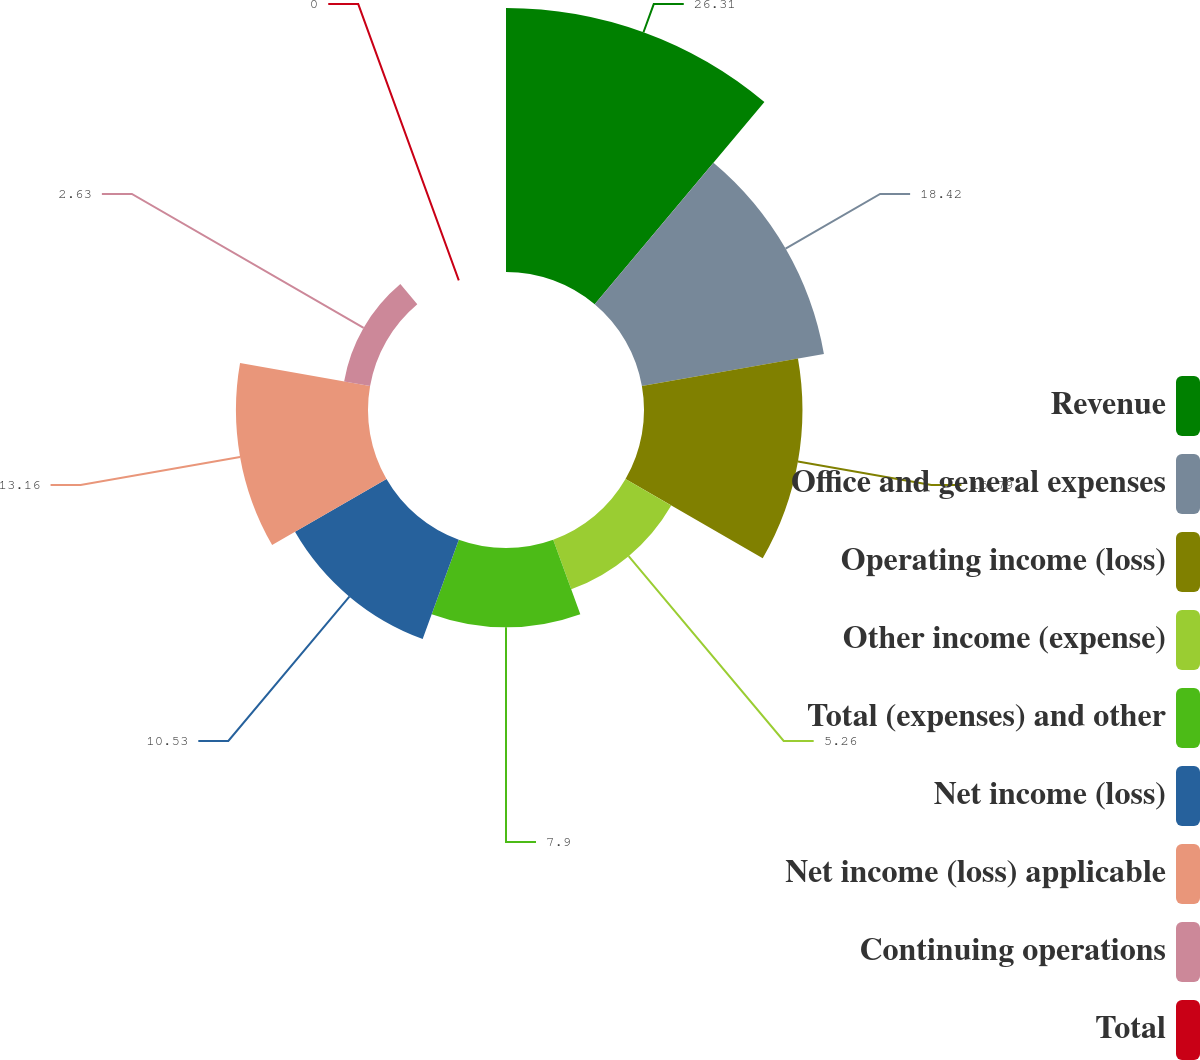<chart> <loc_0><loc_0><loc_500><loc_500><pie_chart><fcel>Revenue<fcel>Office and general expenses<fcel>Operating income (loss)<fcel>Other income (expense)<fcel>Total (expenses) and other<fcel>Net income (loss)<fcel>Net income (loss) applicable<fcel>Continuing operations<fcel>Total<nl><fcel>26.31%<fcel>18.42%<fcel>15.79%<fcel>5.26%<fcel>7.9%<fcel>10.53%<fcel>13.16%<fcel>2.63%<fcel>0.0%<nl></chart> 